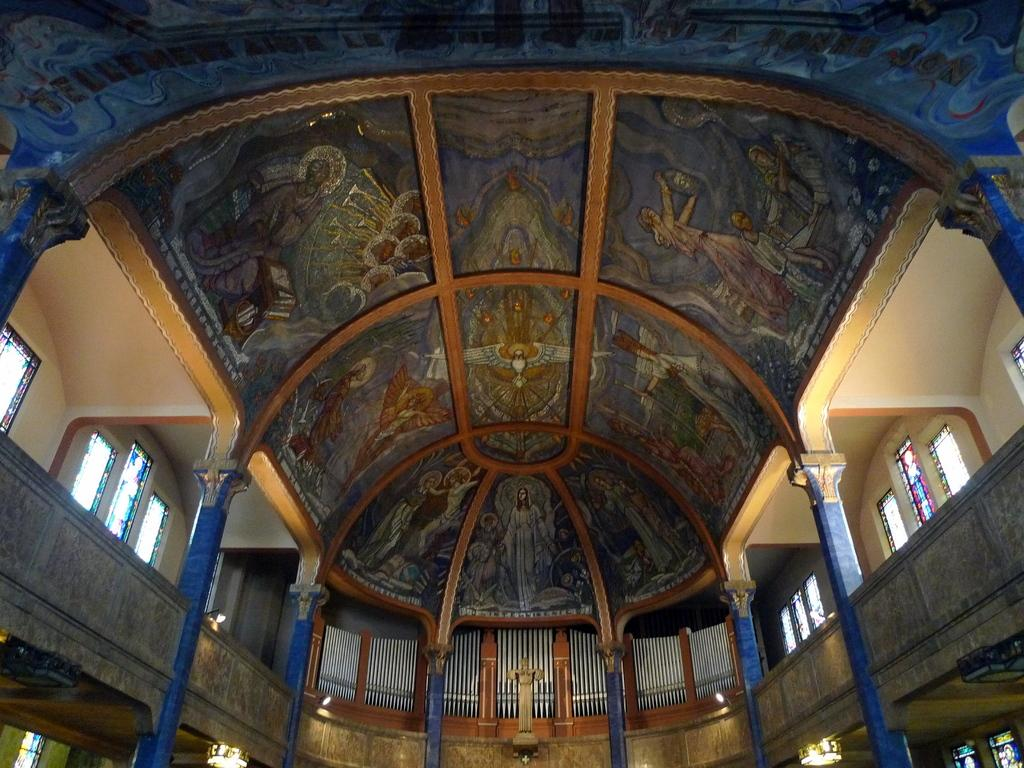What type of location is depicted in the image? The image is an inside view of a building. What structural elements can be seen in the image? There are walls, windows, pillars, and a roof in the image. Are there any decorative or artistic elements in the image? Yes, there is a statue and chandeliers in the image. What type of lighting is present in the image? There are lights and chandeliers in the image. Are there any additional objects or features in the image? Yes, there are boards in the image. Can you tell me how many goldfish are swimming in the fountain in the image? There is no fountain or goldfish present in the image. What type of plants can be seen growing on the statue in the image? There is no plant growth on the statue in the image. 